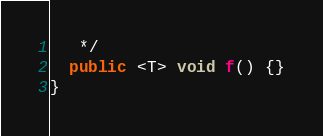<code> <loc_0><loc_0><loc_500><loc_500><_Java_>   */
  public <T> void f() {}
}</code> 